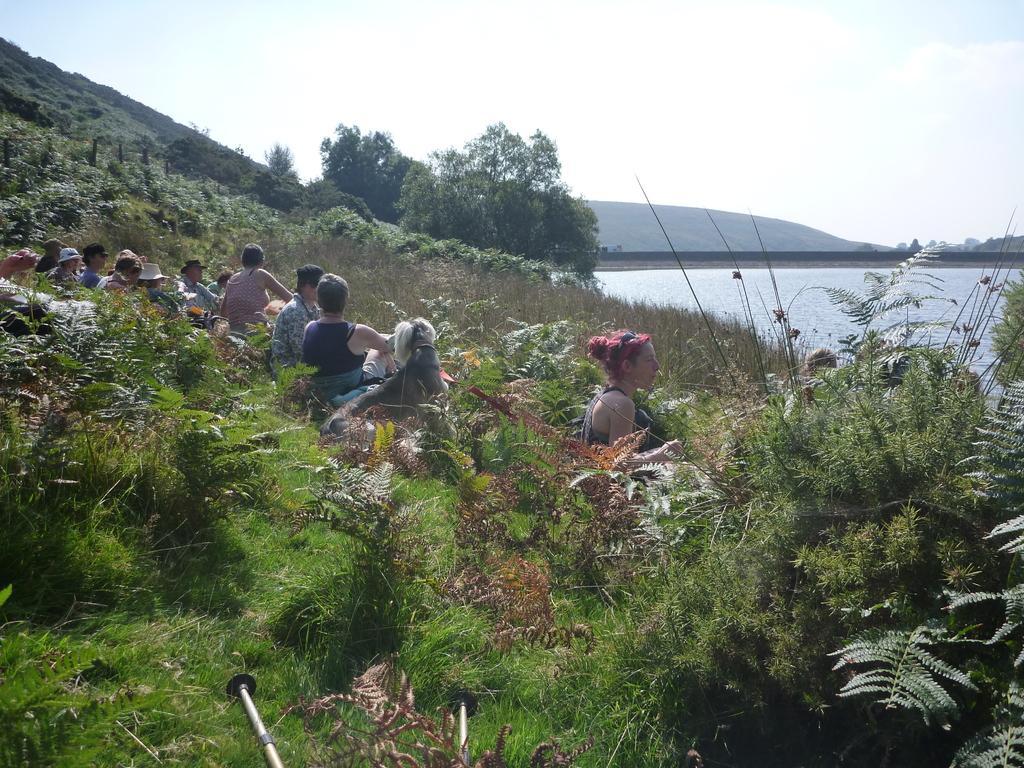How would you summarize this image in a sentence or two? In this image we can see some people sitting. And we can see the grass, plants and the surrounding trees. And we can see the water. And we can see the hill. And we can see the sky. And we can see some other objects. 